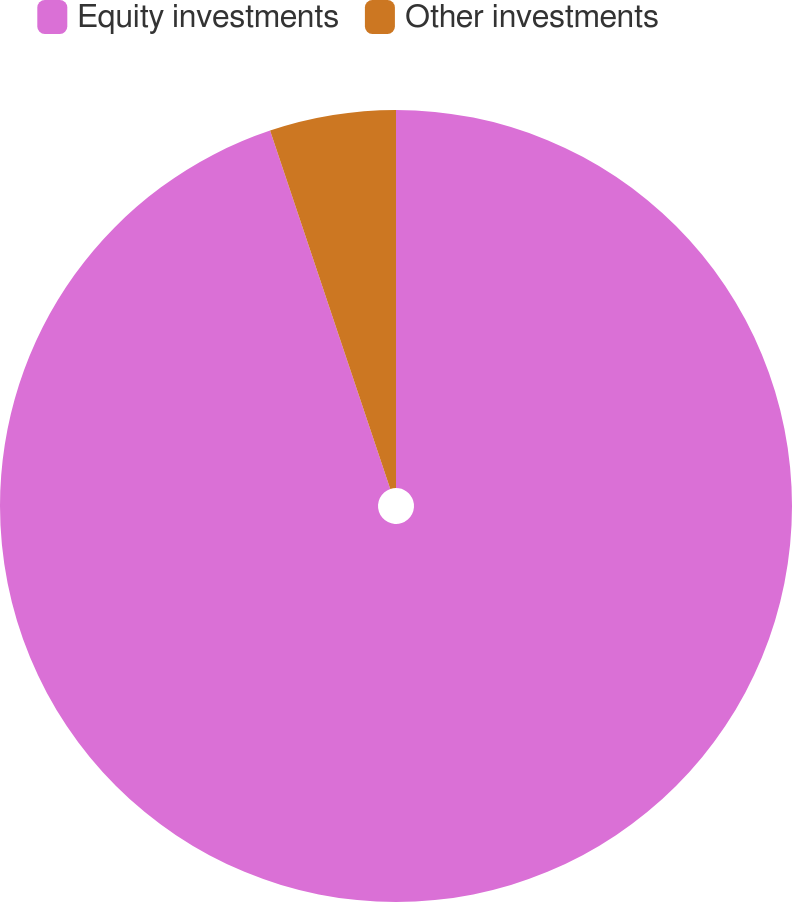<chart> <loc_0><loc_0><loc_500><loc_500><pie_chart><fcel>Equity investments<fcel>Other investments<nl><fcel>94.85%<fcel>5.15%<nl></chart> 